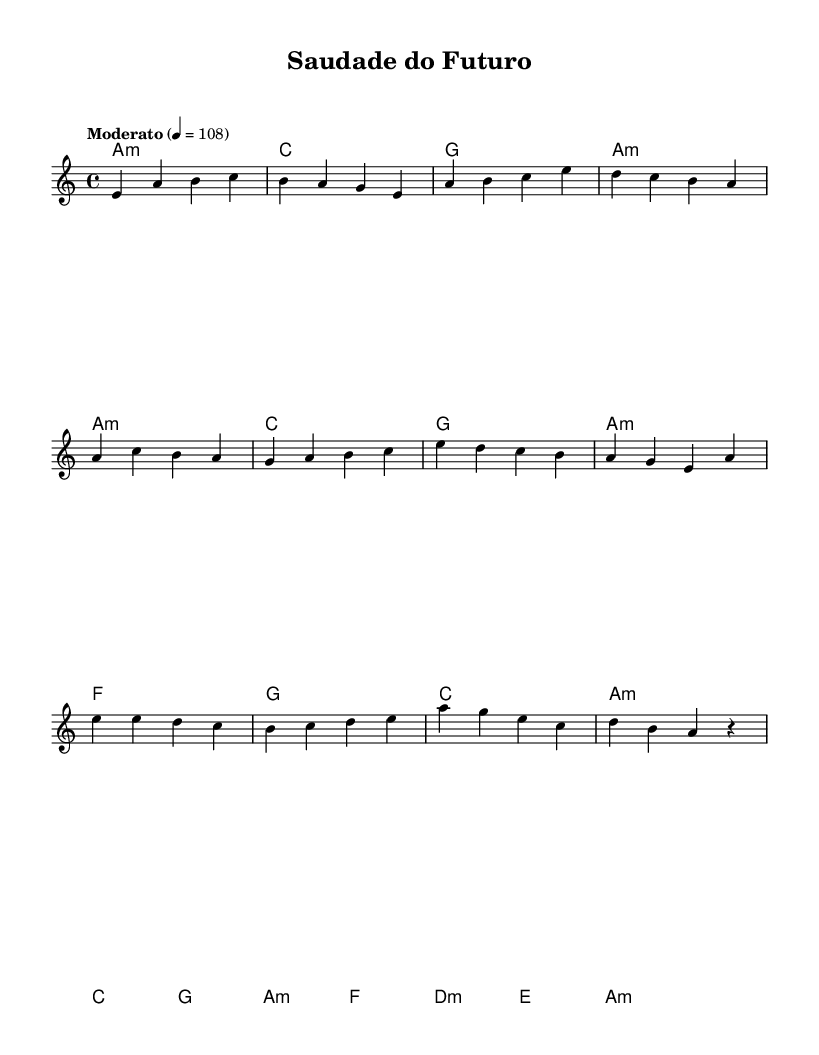What is the key signature of this music? The key signature is A minor, which indicates that there are no sharps or flats aside from the natural key notes. This can be determined by the absence of sharps or flats at the beginning of the staff on the sheet music.
Answer: A minor What is the time signature of the piece? The time signature is four-four, written as 4/4. This indicates that there are four beats in each measure and the quarter note receives one beat, which can be observed at the beginning of the sheet music.
Answer: Four-four What is the tempo marking for this piece? The tempo marking is "Moderato," with a metronome marking of quarter note equals 108, indicating a moderate pace. This is located at the beginning of the score next to the tempo indication.
Answer: Moderato How many measures are in the intro section? There are four measures in the intro section, which can be counted by observing the division lines in the music notation before the verse begins.
Answer: Four What is the first chord in the harmonies? The first chord in the harmonies is A minor, indicated by the notation specifying a minor chord on the first measure. The symbol "a:m" signifies this.
Answer: A minor In which section does the melody first reach an E note? The melody first reaches an E note in the chorus section. By tracing the melody line, one can see that the first E appears in the eighth measure of the melody.
Answer: Chorus What type of fusion does this music represent? This music represents a fusion of 1970s Latin rock and traditional Portuguese fado, a unique blend characterized by the emotional depth of fado with the rhythmic and melodic elements typical of Latin rock. This can be inferred from both the style of melodies and chord structures prevalent in the piece.
Answer: Latin rock and fado 